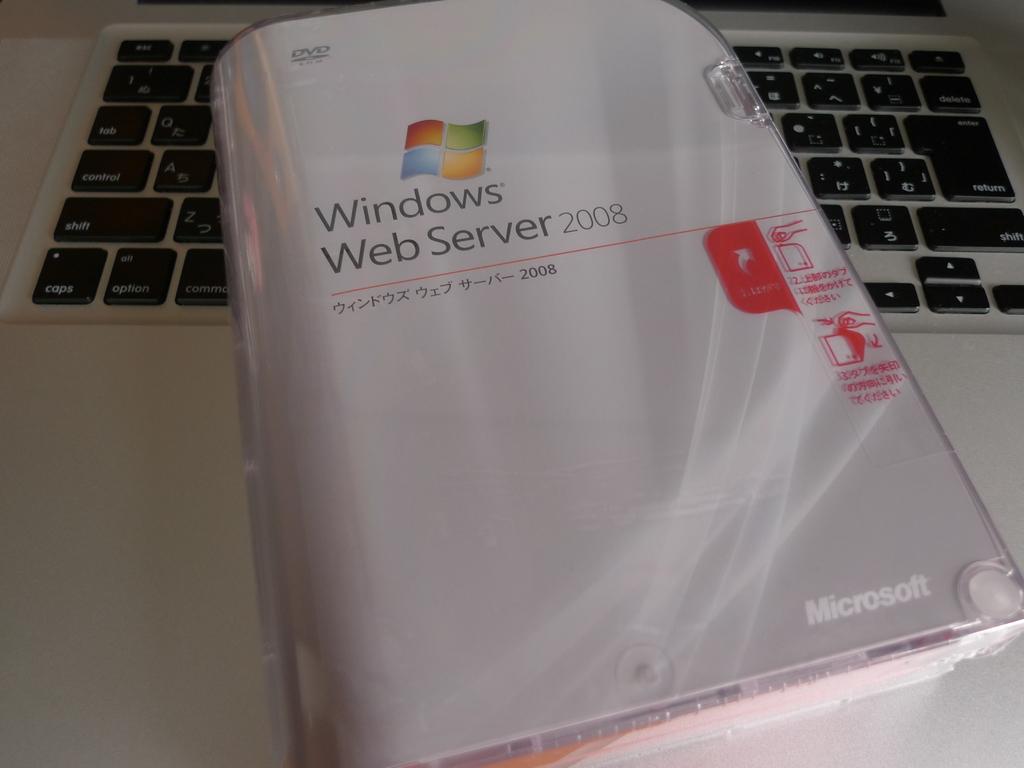What year was this server?
Offer a terse response. 2008. What brand is the windows web server?
Your response must be concise. Microsoft. 